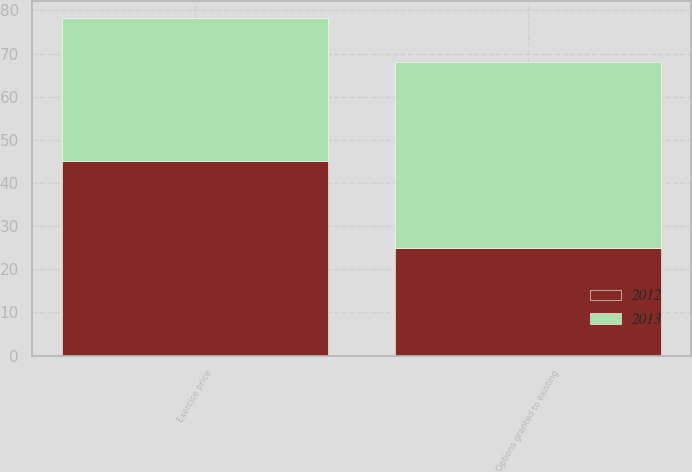<chart> <loc_0><loc_0><loc_500><loc_500><stacked_bar_chart><ecel><fcel>Options granted to existing<fcel>Exercise price<nl><fcel>2012<fcel>25<fcel>45.03<nl><fcel>2013<fcel>43<fcel>33.18<nl></chart> 